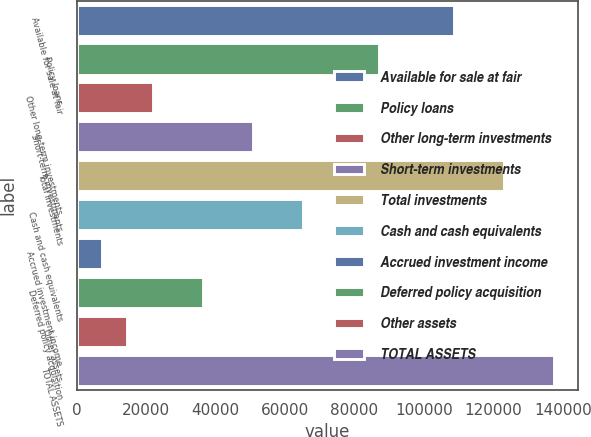<chart> <loc_0><loc_0><loc_500><loc_500><bar_chart><fcel>Available for sale at fair<fcel>Policy loans<fcel>Other long-term investments<fcel>Short-term investments<fcel>Total investments<fcel>Cash and cash equivalents<fcel>Accrued investment income<fcel>Deferred policy acquisition<fcel>Other assets<fcel>TOTAL ASSETS<nl><fcel>108664<fcel>86956.8<fcel>21833.7<fcel>50777.3<fcel>123136<fcel>65249.1<fcel>7361.9<fcel>36305.5<fcel>14597.8<fcel>137608<nl></chart> 